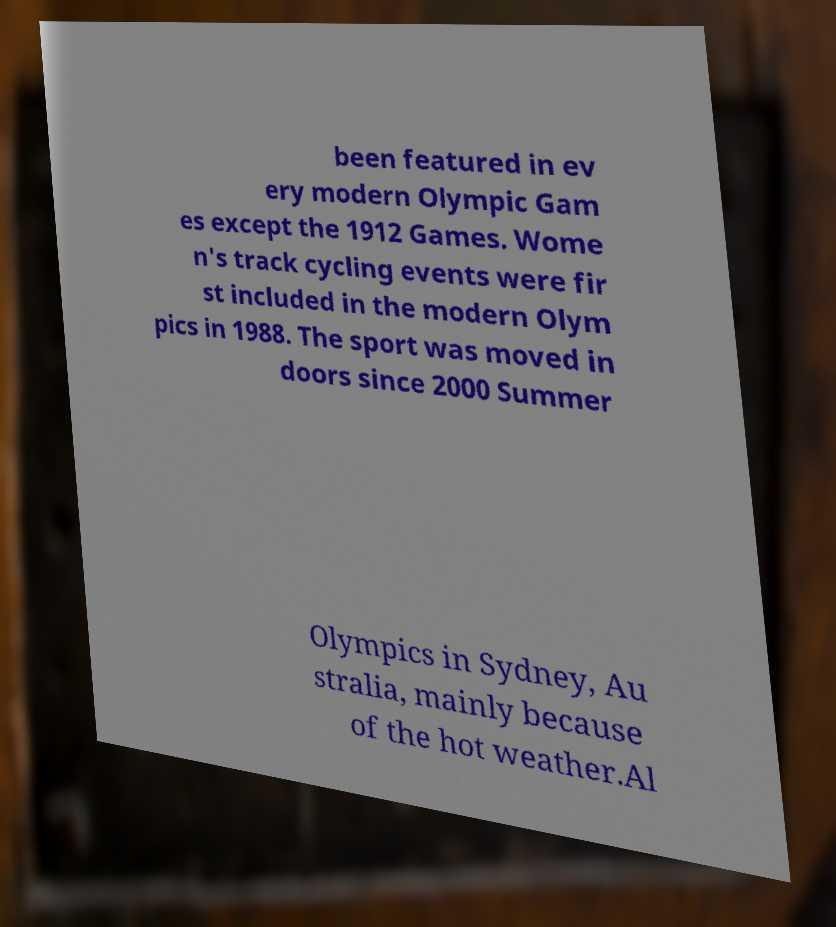For documentation purposes, I need the text within this image transcribed. Could you provide that? been featured in ev ery modern Olympic Gam es except the 1912 Games. Wome n's track cycling events were fir st included in the modern Olym pics in 1988. The sport was moved in doors since 2000 Summer Olympics in Sydney, Au stralia, mainly because of the hot weather.Al 